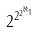<formula> <loc_0><loc_0><loc_500><loc_500>2 ^ { 2 ^ { 2 ^ { \aleph _ { 1 } } } }</formula> 